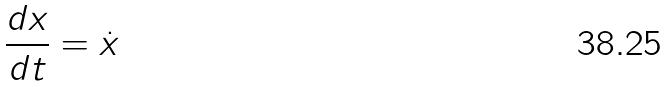<formula> <loc_0><loc_0><loc_500><loc_500>\frac { d x } { d t } = \dot { x }</formula> 